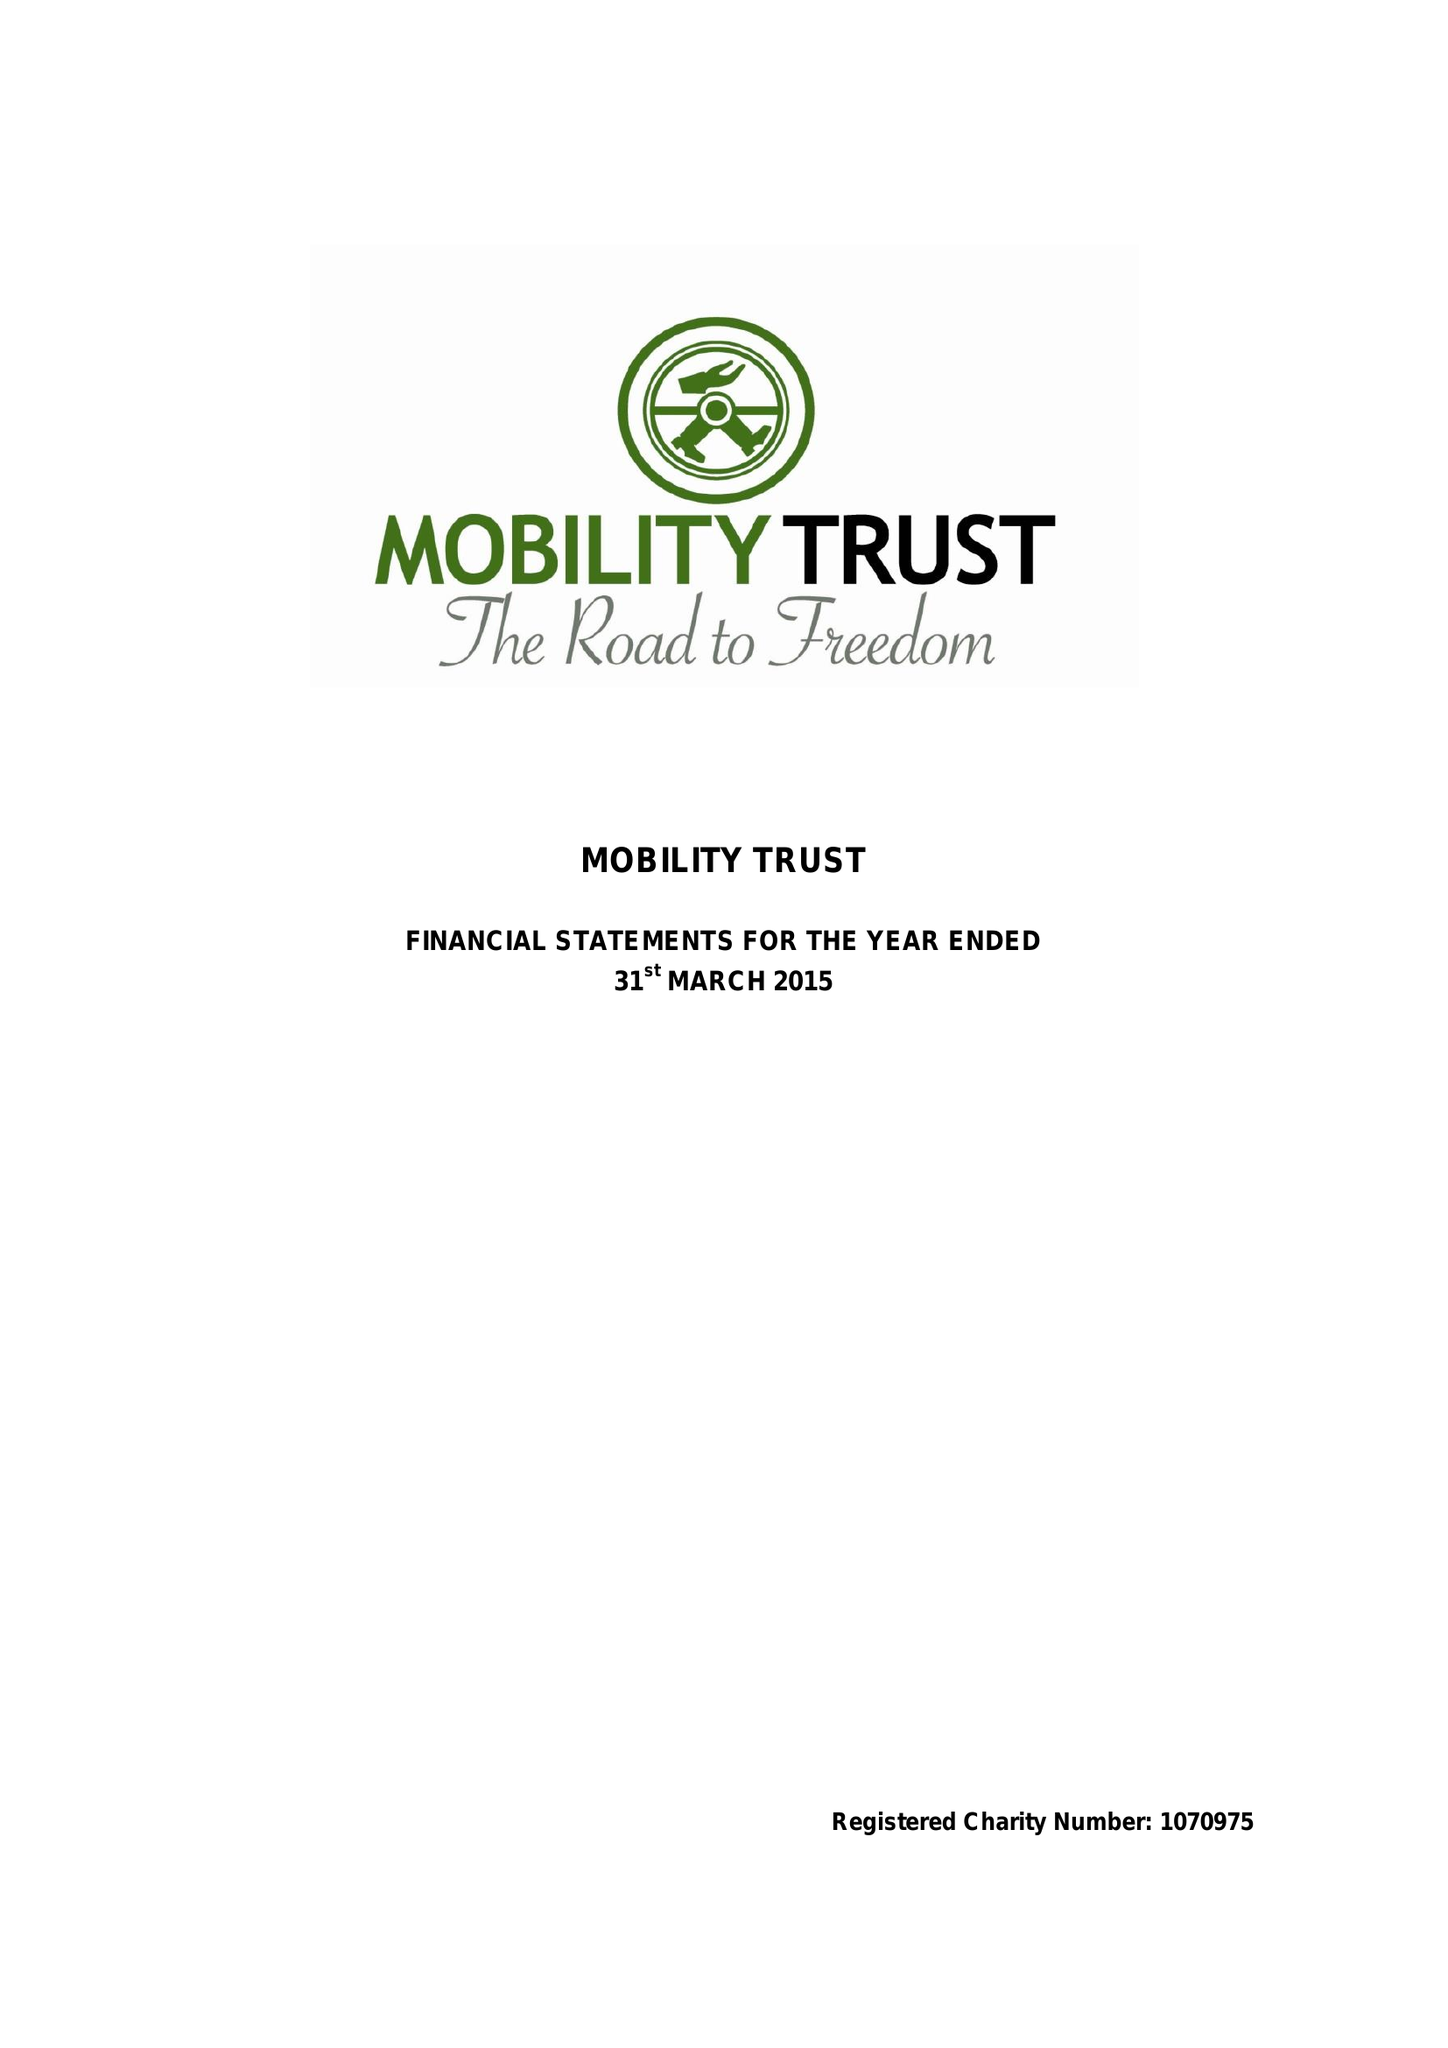What is the value for the address__postcode?
Answer the question using a single word or phrase. RG8 7LR 